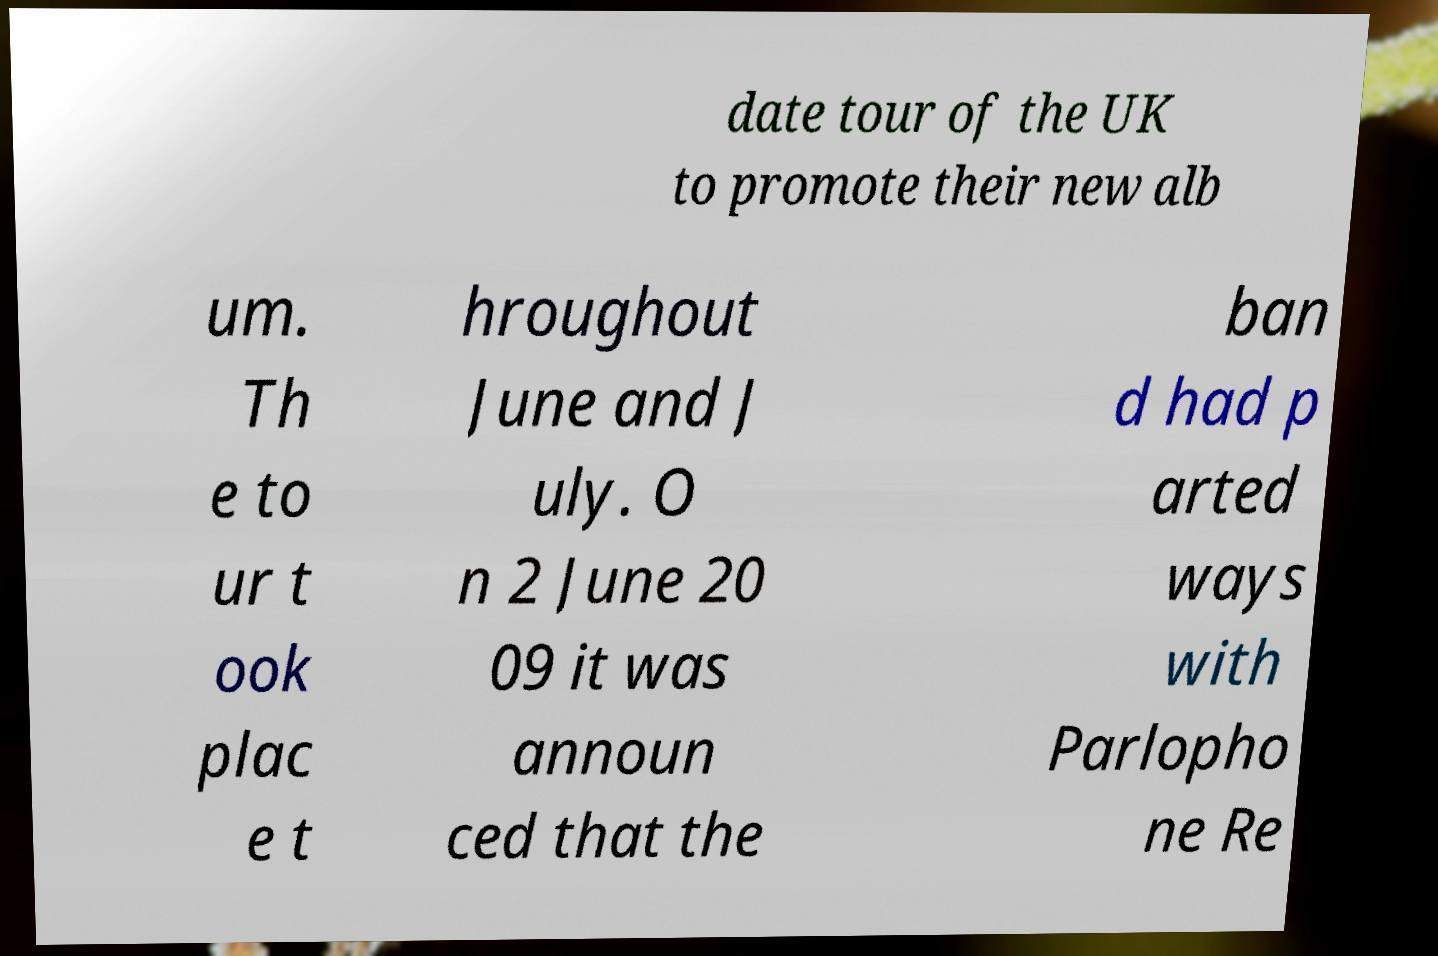There's text embedded in this image that I need extracted. Can you transcribe it verbatim? date tour of the UK to promote their new alb um. Th e to ur t ook plac e t hroughout June and J uly. O n 2 June 20 09 it was announ ced that the ban d had p arted ways with Parlopho ne Re 